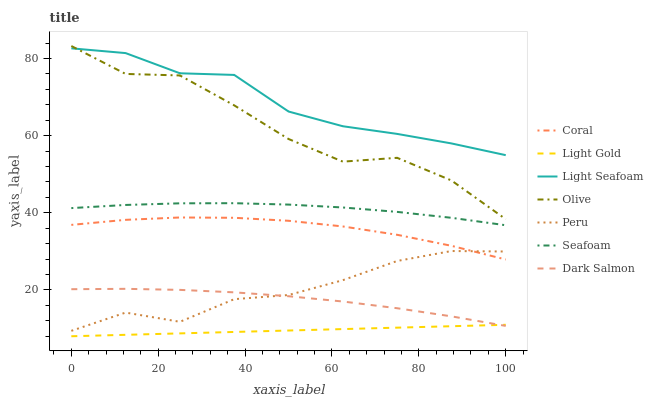Does Light Gold have the minimum area under the curve?
Answer yes or no. Yes. Does Light Seafoam have the maximum area under the curve?
Answer yes or no. Yes. Does Seafoam have the minimum area under the curve?
Answer yes or no. No. Does Seafoam have the maximum area under the curve?
Answer yes or no. No. Is Light Gold the smoothest?
Answer yes or no. Yes. Is Olive the roughest?
Answer yes or no. Yes. Is Seafoam the smoothest?
Answer yes or no. No. Is Seafoam the roughest?
Answer yes or no. No. Does Seafoam have the lowest value?
Answer yes or no. No. Does Seafoam have the highest value?
Answer yes or no. No. Is Light Gold less than Peru?
Answer yes or no. Yes. Is Olive greater than Peru?
Answer yes or no. Yes. Does Light Gold intersect Peru?
Answer yes or no. No. 